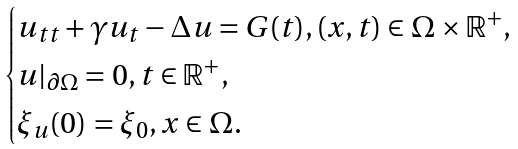<formula> <loc_0><loc_0><loc_500><loc_500>\begin{cases} u _ { t t } + \gamma u _ { t } - \Delta u = G ( t ) , ( x , t ) \in \Omega \times \mathbb { R } ^ { + } , \\ u | _ { \partial \Omega } = 0 , t \in \mathbb { R } ^ { + } , \\ \xi _ { u } ( 0 ) = \xi _ { 0 } , x \in \Omega . \end{cases}</formula> 